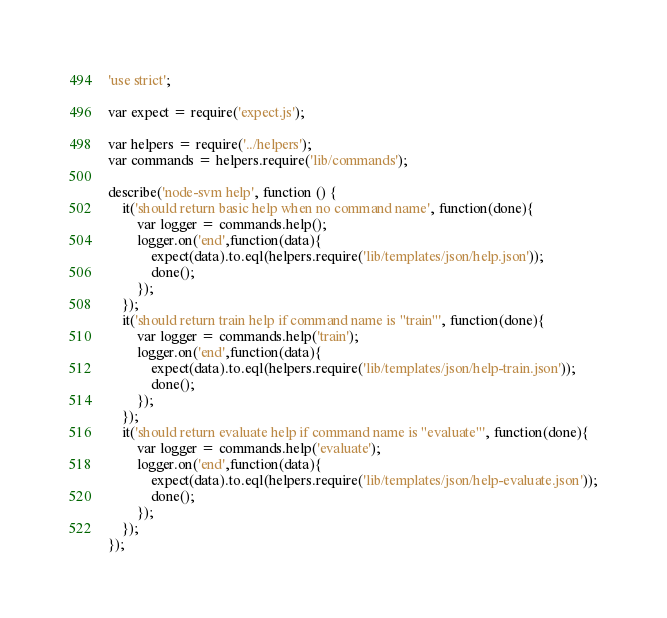<code> <loc_0><loc_0><loc_500><loc_500><_JavaScript_>'use strict';

var expect = require('expect.js');

var helpers = require('../helpers');
var commands = helpers.require('lib/commands');

describe('node-svm help', function () {
    it('should return basic help when no command name', function(done){
        var logger = commands.help();
        logger.on('end',function(data){
            expect(data).to.eql(helpers.require('lib/templates/json/help.json'));
            done();
        });
    });
    it('should return train help if command name is "train"', function(done){
        var logger = commands.help('train');
        logger.on('end',function(data){
            expect(data).to.eql(helpers.require('lib/templates/json/help-train.json'));
            done();
        });
    });
    it('should return evaluate help if command name is "evaluate"', function(done){
        var logger = commands.help('evaluate');
        logger.on('end',function(data){
            expect(data).to.eql(helpers.require('lib/templates/json/help-evaluate.json'));
            done();
        });
    });
});</code> 